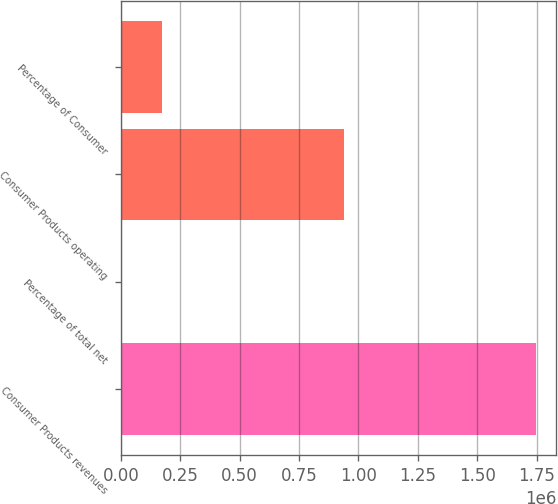<chart> <loc_0><loc_0><loc_500><loc_500><bar_chart><fcel>Consumer Products revenues<fcel>Percentage of total net<fcel>Consumer Products operating<fcel>Percentage of Consumer<nl><fcel>1.74609e+06<fcel>30<fcel>938627<fcel>174636<nl></chart> 